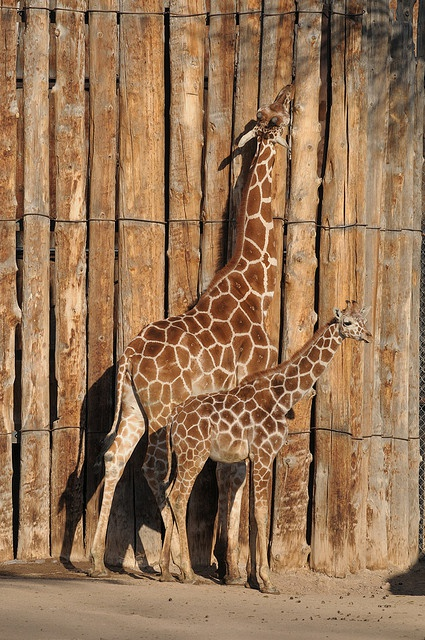Describe the objects in this image and their specific colors. I can see giraffe in tan, brown, maroon, and gray tones and giraffe in tan, gray, brown, and maroon tones in this image. 